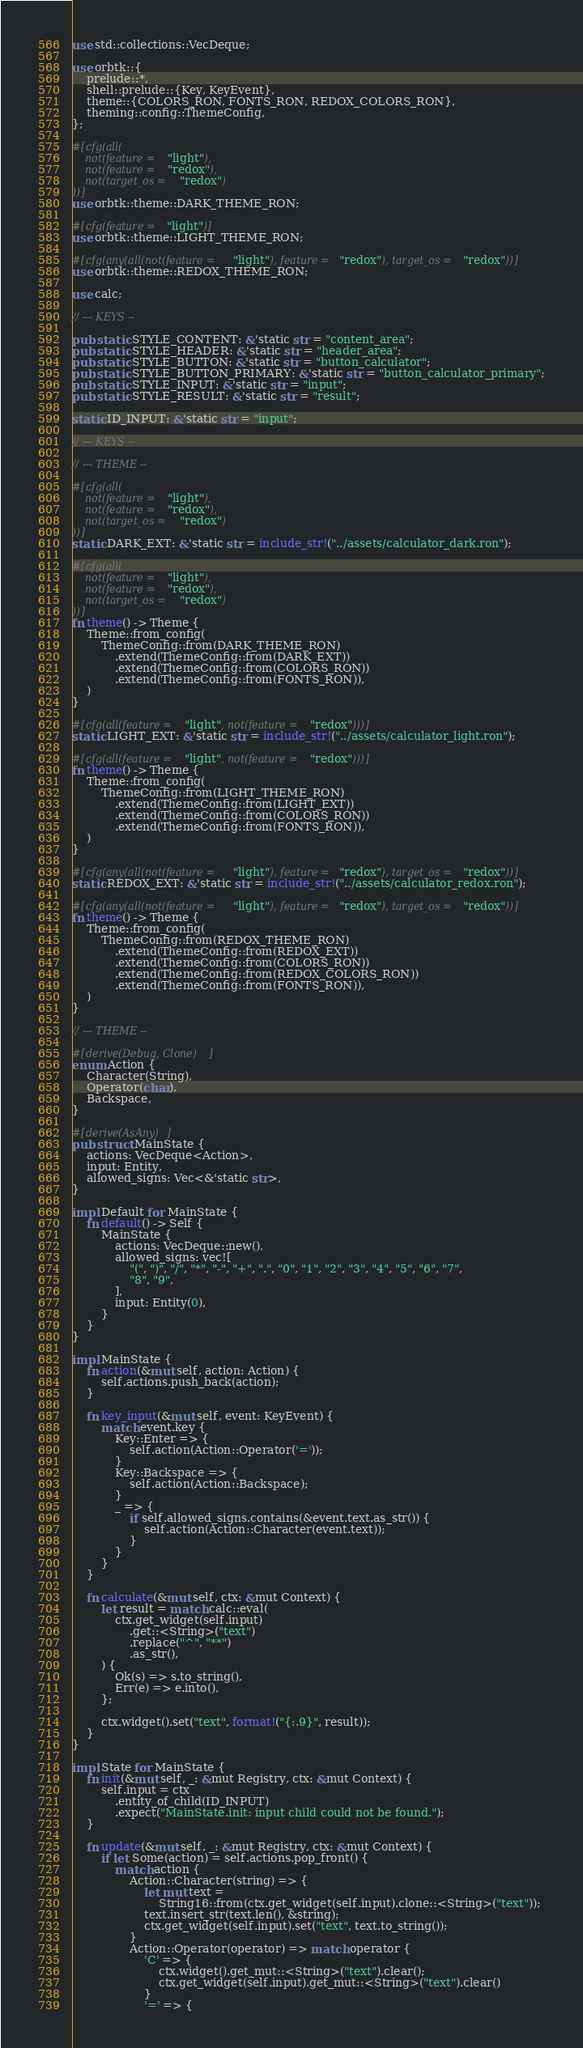<code> <loc_0><loc_0><loc_500><loc_500><_Rust_>use std::collections::VecDeque;

use orbtk::{
    prelude::*,
    shell::prelude::{Key, KeyEvent},
    theme::{COLORS_RON, FONTS_RON, REDOX_COLORS_RON},
    theming::config::ThemeConfig,
};

#[cfg(all(
    not(feature = "light"),
    not(feature = "redox"),
    not(target_os = "redox")
))]
use orbtk::theme::DARK_THEME_RON;

#[cfg(feature = "light")]
use orbtk::theme::LIGHT_THEME_RON;

#[cfg(any(all(not(feature = "light"), feature = "redox"), target_os = "redox"))]
use orbtk::theme::REDOX_THEME_RON;

use calc;

// --- KEYS --

pub static STYLE_CONTENT: &'static str = "content_area";
pub static STYLE_HEADER: &'static str = "header_area";
pub static STYLE_BUTTON: &'static str = "button_calculator";
pub static STYLE_BUTTON_PRIMARY: &'static str = "button_calculator_primary";
pub static STYLE_INPUT: &'static str = "input";
pub static STYLE_RESULT: &'static str = "result";

static ID_INPUT: &'static str = "input";

// --- KEYS --

// --- THEME --

#[cfg(all(
    not(feature = "light"),
    not(feature = "redox"),
    not(target_os = "redox")
))]
static DARK_EXT: &'static str = include_str!("../assets/calculator_dark.ron");

#[cfg(all(
    not(feature = "light"),
    not(feature = "redox"),
    not(target_os = "redox")
))]
fn theme() -> Theme {
    Theme::from_config(
        ThemeConfig::from(DARK_THEME_RON)
            .extend(ThemeConfig::from(DARK_EXT))
            .extend(ThemeConfig::from(COLORS_RON))
            .extend(ThemeConfig::from(FONTS_RON)),
    )
}

#[cfg(all(feature = "light", not(feature = "redox")))]
static LIGHT_EXT: &'static str = include_str!("../assets/calculator_light.ron");

#[cfg(all(feature = "light", not(feature = "redox")))]
fn theme() -> Theme {
    Theme::from_config(
        ThemeConfig::from(LIGHT_THEME_RON)
            .extend(ThemeConfig::from(LIGHT_EXT))
            .extend(ThemeConfig::from(COLORS_RON))
            .extend(ThemeConfig::from(FONTS_RON)),
    )
}

#[cfg(any(all(not(feature = "light"), feature = "redox"), target_os = "redox"))]
static REDOX_EXT: &'static str = include_str!("../assets/calculator_redox.ron");

#[cfg(any(all(not(feature = "light"), feature = "redox"), target_os = "redox"))]
fn theme() -> Theme {
    Theme::from_config(
        ThemeConfig::from(REDOX_THEME_RON)
            .extend(ThemeConfig::from(REDOX_EXT))
            .extend(ThemeConfig::from(COLORS_RON))
            .extend(ThemeConfig::from(REDOX_COLORS_RON))
            .extend(ThemeConfig::from(FONTS_RON)),
    )
}

// --- THEME --

#[derive(Debug, Clone)]
enum Action {
    Character(String),
    Operator(char),
    Backspace,
}

#[derive(AsAny)]
pub struct MainState {
    actions: VecDeque<Action>,
    input: Entity,
    allowed_signs: Vec<&'static str>,
}

impl Default for MainState {
    fn default() -> Self {
        MainState {
            actions: VecDeque::new(),
            allowed_signs: vec![
                "(", ")", "/", "*", "-", "+", ".", "0", "1", "2", "3", "4", "5", "6", "7",
                "8", "9",
            ],
            input: Entity(0),
        }
    }
}

impl MainState {
    fn action(&mut self, action: Action) {
        self.actions.push_back(action);
    }

    fn key_input(&mut self, event: KeyEvent) {
        match event.key {
            Key::Enter => {
                self.action(Action::Operator('='));
            }
            Key::Backspace => {
                self.action(Action::Backspace);
            }
            _ => {
                if self.allowed_signs.contains(&event.text.as_str()) {
                    self.action(Action::Character(event.text));
                }
            }
        }
    }

    fn calculate(&mut self, ctx: &mut Context) {
        let result = match calc::eval(
            ctx.get_widget(self.input)
                .get::<String>("text")
                .replace("^", "**")
                .as_str(),
        ) {
            Ok(s) => s.to_string(),
            Err(e) => e.into(),
        };

        ctx.widget().set("text", format!("{:.9}", result));
    }
}

impl State for MainState {
    fn init(&mut self, _: &mut Registry, ctx: &mut Context) {
        self.input = ctx
            .entity_of_child(ID_INPUT)
            .expect("MainState.init: input child could not be found.");
    }

    fn update(&mut self, _: &mut Registry, ctx: &mut Context) {
        if let Some(action) = self.actions.pop_front() {
            match action {
                Action::Character(string) => {
                    let mut text =
                        String16::from(ctx.get_widget(self.input).clone::<String>("text"));
                    text.insert_str(text.len(), &string);
                    ctx.get_widget(self.input).set("text", text.to_string());
                }
                Action::Operator(operator) => match operator {
                    'C' => {
                        ctx.widget().get_mut::<String>("text").clear();
                        ctx.get_widget(self.input).get_mut::<String>("text").clear()
                    }
                    '=' => {</code> 